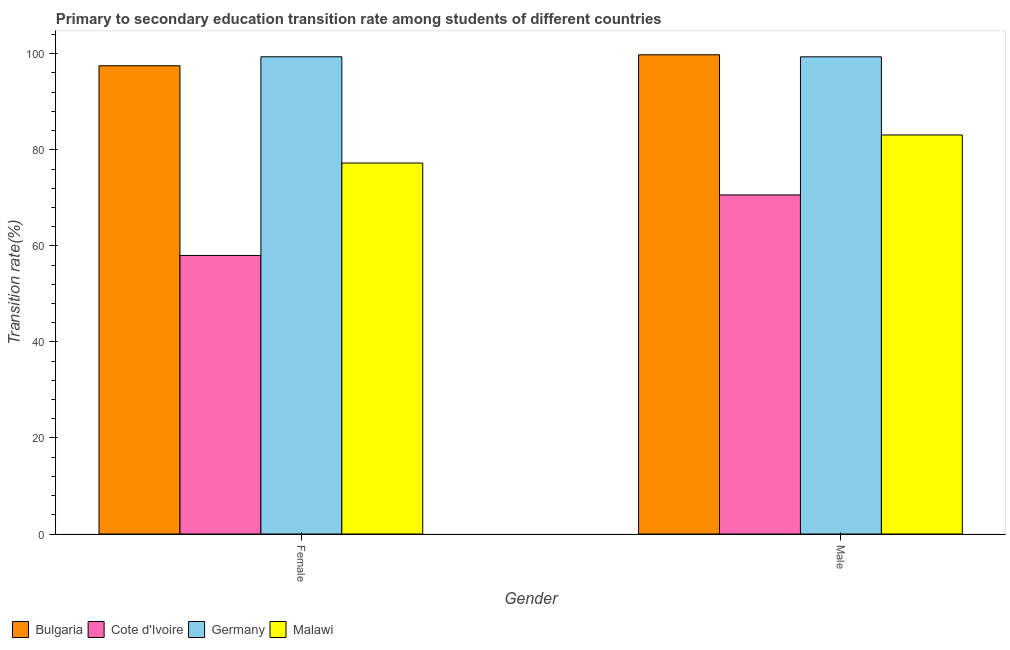Are the number of bars per tick equal to the number of legend labels?
Make the answer very short. Yes. Are the number of bars on each tick of the X-axis equal?
Give a very brief answer. Yes. How many bars are there on the 1st tick from the left?
Keep it short and to the point. 4. How many bars are there on the 1st tick from the right?
Your answer should be compact. 4. What is the label of the 1st group of bars from the left?
Make the answer very short. Female. What is the transition rate among female students in Bulgaria?
Offer a terse response. 97.5. Across all countries, what is the maximum transition rate among male students?
Provide a short and direct response. 99.78. Across all countries, what is the minimum transition rate among female students?
Provide a succinct answer. 58. In which country was the transition rate among male students maximum?
Make the answer very short. Bulgaria. In which country was the transition rate among male students minimum?
Your response must be concise. Cote d'Ivoire. What is the total transition rate among female students in the graph?
Your response must be concise. 332.12. What is the difference between the transition rate among male students in Malawi and that in Bulgaria?
Make the answer very short. -16.7. What is the difference between the transition rate among male students in Germany and the transition rate among female students in Cote d'Ivoire?
Keep it short and to the point. 41.36. What is the average transition rate among male students per country?
Offer a very short reply. 88.21. What is the difference between the transition rate among male students and transition rate among female students in Germany?
Your answer should be very brief. -0.01. In how many countries, is the transition rate among female students greater than 8 %?
Your answer should be compact. 4. What is the ratio of the transition rate among male students in Malawi to that in Germany?
Your answer should be very brief. 0.84. Is the transition rate among male students in Cote d'Ivoire less than that in Malawi?
Provide a succinct answer. Yes. In how many countries, is the transition rate among female students greater than the average transition rate among female students taken over all countries?
Your response must be concise. 2. What does the 2nd bar from the right in Female represents?
Provide a short and direct response. Germany. Are all the bars in the graph horizontal?
Offer a very short reply. No. Does the graph contain any zero values?
Keep it short and to the point. No. Where does the legend appear in the graph?
Provide a short and direct response. Bottom left. How many legend labels are there?
Your answer should be very brief. 4. What is the title of the graph?
Provide a short and direct response. Primary to secondary education transition rate among students of different countries. What is the label or title of the X-axis?
Give a very brief answer. Gender. What is the label or title of the Y-axis?
Offer a very short reply. Transition rate(%). What is the Transition rate(%) of Bulgaria in Female?
Your answer should be very brief. 97.5. What is the Transition rate(%) of Cote d'Ivoire in Female?
Ensure brevity in your answer.  58. What is the Transition rate(%) in Germany in Female?
Provide a short and direct response. 99.37. What is the Transition rate(%) in Malawi in Female?
Ensure brevity in your answer.  77.24. What is the Transition rate(%) of Bulgaria in Male?
Make the answer very short. 99.78. What is the Transition rate(%) of Cote d'Ivoire in Male?
Offer a very short reply. 70.6. What is the Transition rate(%) in Germany in Male?
Ensure brevity in your answer.  99.36. What is the Transition rate(%) of Malawi in Male?
Provide a short and direct response. 83.09. Across all Gender, what is the maximum Transition rate(%) in Bulgaria?
Offer a terse response. 99.78. Across all Gender, what is the maximum Transition rate(%) in Cote d'Ivoire?
Provide a short and direct response. 70.6. Across all Gender, what is the maximum Transition rate(%) in Germany?
Offer a very short reply. 99.37. Across all Gender, what is the maximum Transition rate(%) in Malawi?
Your response must be concise. 83.09. Across all Gender, what is the minimum Transition rate(%) of Bulgaria?
Your answer should be compact. 97.5. Across all Gender, what is the minimum Transition rate(%) in Cote d'Ivoire?
Keep it short and to the point. 58. Across all Gender, what is the minimum Transition rate(%) of Germany?
Your answer should be very brief. 99.36. Across all Gender, what is the minimum Transition rate(%) of Malawi?
Offer a very short reply. 77.24. What is the total Transition rate(%) of Bulgaria in the graph?
Your answer should be compact. 197.28. What is the total Transition rate(%) in Cote d'Ivoire in the graph?
Your answer should be very brief. 128.6. What is the total Transition rate(%) of Germany in the graph?
Make the answer very short. 198.73. What is the total Transition rate(%) of Malawi in the graph?
Ensure brevity in your answer.  160.33. What is the difference between the Transition rate(%) of Bulgaria in Female and that in Male?
Make the answer very short. -2.28. What is the difference between the Transition rate(%) in Cote d'Ivoire in Female and that in Male?
Provide a short and direct response. -12.6. What is the difference between the Transition rate(%) of Germany in Female and that in Male?
Make the answer very short. 0.01. What is the difference between the Transition rate(%) of Malawi in Female and that in Male?
Keep it short and to the point. -5.84. What is the difference between the Transition rate(%) in Bulgaria in Female and the Transition rate(%) in Cote d'Ivoire in Male?
Make the answer very short. 26.9. What is the difference between the Transition rate(%) in Bulgaria in Female and the Transition rate(%) in Germany in Male?
Your answer should be compact. -1.86. What is the difference between the Transition rate(%) in Bulgaria in Female and the Transition rate(%) in Malawi in Male?
Provide a succinct answer. 14.41. What is the difference between the Transition rate(%) of Cote d'Ivoire in Female and the Transition rate(%) of Germany in Male?
Your response must be concise. -41.36. What is the difference between the Transition rate(%) in Cote d'Ivoire in Female and the Transition rate(%) in Malawi in Male?
Your answer should be very brief. -25.09. What is the difference between the Transition rate(%) in Germany in Female and the Transition rate(%) in Malawi in Male?
Your response must be concise. 16.28. What is the average Transition rate(%) of Bulgaria per Gender?
Offer a terse response. 98.64. What is the average Transition rate(%) in Cote d'Ivoire per Gender?
Ensure brevity in your answer.  64.3. What is the average Transition rate(%) of Germany per Gender?
Keep it short and to the point. 99.36. What is the average Transition rate(%) in Malawi per Gender?
Ensure brevity in your answer.  80.17. What is the difference between the Transition rate(%) in Bulgaria and Transition rate(%) in Cote d'Ivoire in Female?
Your answer should be compact. 39.5. What is the difference between the Transition rate(%) of Bulgaria and Transition rate(%) of Germany in Female?
Your answer should be very brief. -1.87. What is the difference between the Transition rate(%) of Bulgaria and Transition rate(%) of Malawi in Female?
Ensure brevity in your answer.  20.25. What is the difference between the Transition rate(%) of Cote d'Ivoire and Transition rate(%) of Germany in Female?
Offer a terse response. -41.37. What is the difference between the Transition rate(%) of Cote d'Ivoire and Transition rate(%) of Malawi in Female?
Provide a short and direct response. -19.24. What is the difference between the Transition rate(%) in Germany and Transition rate(%) in Malawi in Female?
Make the answer very short. 22.12. What is the difference between the Transition rate(%) of Bulgaria and Transition rate(%) of Cote d'Ivoire in Male?
Provide a succinct answer. 29.18. What is the difference between the Transition rate(%) of Bulgaria and Transition rate(%) of Germany in Male?
Your response must be concise. 0.42. What is the difference between the Transition rate(%) of Bulgaria and Transition rate(%) of Malawi in Male?
Give a very brief answer. 16.7. What is the difference between the Transition rate(%) in Cote d'Ivoire and Transition rate(%) in Germany in Male?
Your response must be concise. -28.76. What is the difference between the Transition rate(%) in Cote d'Ivoire and Transition rate(%) in Malawi in Male?
Keep it short and to the point. -12.49. What is the difference between the Transition rate(%) in Germany and Transition rate(%) in Malawi in Male?
Make the answer very short. 16.27. What is the ratio of the Transition rate(%) of Bulgaria in Female to that in Male?
Your answer should be compact. 0.98. What is the ratio of the Transition rate(%) in Cote d'Ivoire in Female to that in Male?
Keep it short and to the point. 0.82. What is the ratio of the Transition rate(%) of Malawi in Female to that in Male?
Provide a succinct answer. 0.93. What is the difference between the highest and the second highest Transition rate(%) in Bulgaria?
Ensure brevity in your answer.  2.28. What is the difference between the highest and the second highest Transition rate(%) in Cote d'Ivoire?
Offer a very short reply. 12.6. What is the difference between the highest and the second highest Transition rate(%) of Germany?
Offer a very short reply. 0.01. What is the difference between the highest and the second highest Transition rate(%) of Malawi?
Offer a very short reply. 5.84. What is the difference between the highest and the lowest Transition rate(%) in Bulgaria?
Provide a succinct answer. 2.28. What is the difference between the highest and the lowest Transition rate(%) of Cote d'Ivoire?
Offer a very short reply. 12.6. What is the difference between the highest and the lowest Transition rate(%) of Germany?
Your response must be concise. 0.01. What is the difference between the highest and the lowest Transition rate(%) of Malawi?
Your answer should be very brief. 5.84. 